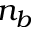<formula> <loc_0><loc_0><loc_500><loc_500>n _ { b }</formula> 